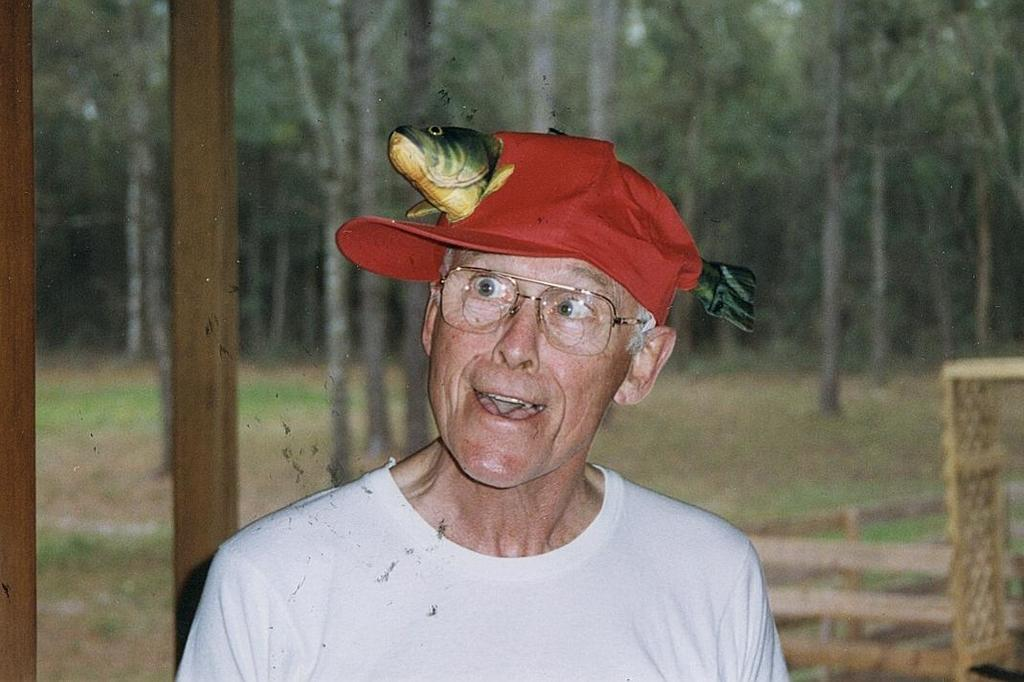Who or what is present in the image? There is a person in the image. What is the person wearing on their head? The person is wearing a cap. What can be seen in the background of the image? There is a poster in the background of the image. What type of lumber is being discussed in the meeting in the image? There is no meeting or discussion of lumber present in the image; it features a person wearing a cap with a poster in the background. 